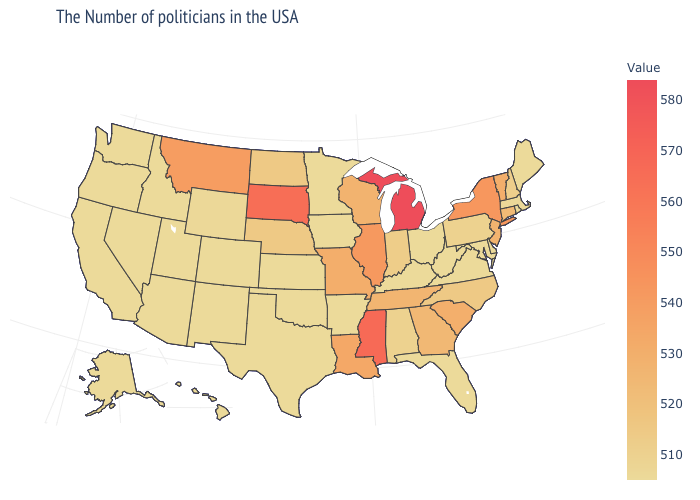Which states have the highest value in the USA?
Give a very brief answer. Michigan. Among the states that border North Carolina , does Georgia have the lowest value?
Be succinct. No. Which states have the lowest value in the MidWest?
Give a very brief answer. Ohio, Minnesota, Iowa, Kansas. Which states have the lowest value in the West?
Quick response, please. Colorado, New Mexico, Utah, Arizona, Idaho, Nevada, California, Washington, Oregon, Alaska, Hawaii. 